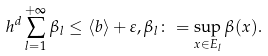<formula> <loc_0><loc_0><loc_500><loc_500>h ^ { d } \sum _ { l = 1 } ^ { + \infty } \beta _ { l } \leq \langle b \rangle + \varepsilon , \beta _ { l } \colon = \sup _ { x \in E _ { l } } \beta ( x ) .</formula> 